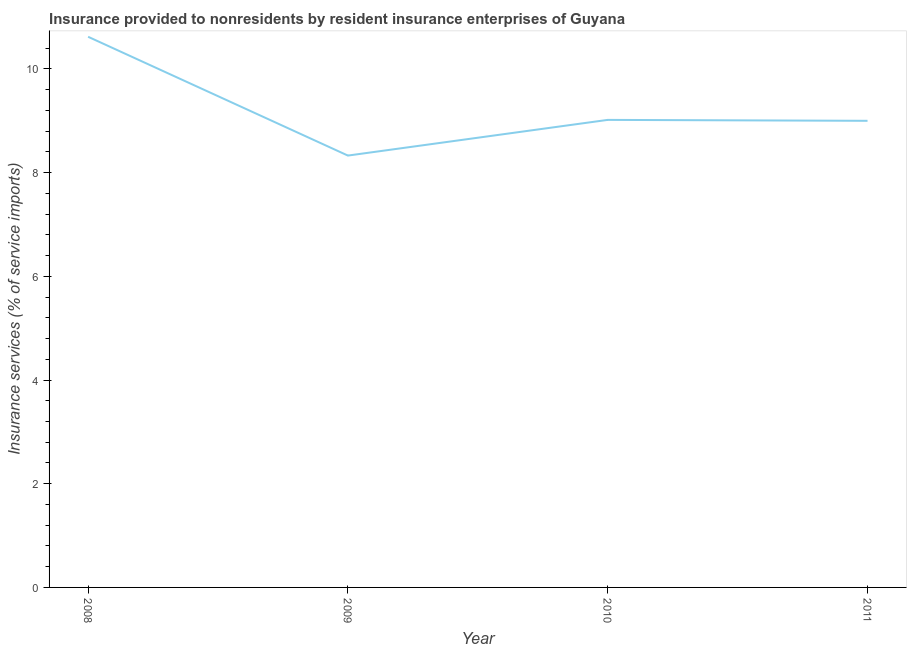What is the insurance and financial services in 2008?
Offer a terse response. 10.62. Across all years, what is the maximum insurance and financial services?
Provide a short and direct response. 10.62. Across all years, what is the minimum insurance and financial services?
Ensure brevity in your answer.  8.33. In which year was the insurance and financial services minimum?
Provide a succinct answer. 2009. What is the sum of the insurance and financial services?
Give a very brief answer. 36.97. What is the difference between the insurance and financial services in 2009 and 2011?
Provide a succinct answer. -0.67. What is the average insurance and financial services per year?
Make the answer very short. 9.24. What is the median insurance and financial services?
Give a very brief answer. 9.01. Do a majority of the years between 2010 and 2011 (inclusive) have insurance and financial services greater than 7.6 %?
Give a very brief answer. Yes. What is the ratio of the insurance and financial services in 2009 to that in 2010?
Make the answer very short. 0.92. Is the insurance and financial services in 2010 less than that in 2011?
Provide a succinct answer. No. Is the difference between the insurance and financial services in 2008 and 2009 greater than the difference between any two years?
Ensure brevity in your answer.  Yes. What is the difference between the highest and the second highest insurance and financial services?
Your response must be concise. 1.6. Is the sum of the insurance and financial services in 2008 and 2011 greater than the maximum insurance and financial services across all years?
Your response must be concise. Yes. What is the difference between the highest and the lowest insurance and financial services?
Your answer should be very brief. 2.29. Does the insurance and financial services monotonically increase over the years?
Keep it short and to the point. No. Does the graph contain any zero values?
Your answer should be compact. No. Does the graph contain grids?
Offer a very short reply. No. What is the title of the graph?
Offer a terse response. Insurance provided to nonresidents by resident insurance enterprises of Guyana. What is the label or title of the Y-axis?
Your answer should be compact. Insurance services (% of service imports). What is the Insurance services (% of service imports) in 2008?
Your answer should be compact. 10.62. What is the Insurance services (% of service imports) in 2009?
Make the answer very short. 8.33. What is the Insurance services (% of service imports) in 2010?
Offer a terse response. 9.02. What is the Insurance services (% of service imports) of 2011?
Your answer should be compact. 9. What is the difference between the Insurance services (% of service imports) in 2008 and 2009?
Provide a succinct answer. 2.29. What is the difference between the Insurance services (% of service imports) in 2008 and 2010?
Offer a terse response. 1.6. What is the difference between the Insurance services (% of service imports) in 2008 and 2011?
Make the answer very short. 1.62. What is the difference between the Insurance services (% of service imports) in 2009 and 2010?
Your response must be concise. -0.69. What is the difference between the Insurance services (% of service imports) in 2009 and 2011?
Offer a terse response. -0.67. What is the difference between the Insurance services (% of service imports) in 2010 and 2011?
Your response must be concise. 0.02. What is the ratio of the Insurance services (% of service imports) in 2008 to that in 2009?
Your answer should be very brief. 1.27. What is the ratio of the Insurance services (% of service imports) in 2008 to that in 2010?
Your answer should be very brief. 1.18. What is the ratio of the Insurance services (% of service imports) in 2008 to that in 2011?
Offer a very short reply. 1.18. What is the ratio of the Insurance services (% of service imports) in 2009 to that in 2010?
Your response must be concise. 0.92. What is the ratio of the Insurance services (% of service imports) in 2009 to that in 2011?
Ensure brevity in your answer.  0.93. What is the ratio of the Insurance services (% of service imports) in 2010 to that in 2011?
Ensure brevity in your answer.  1. 